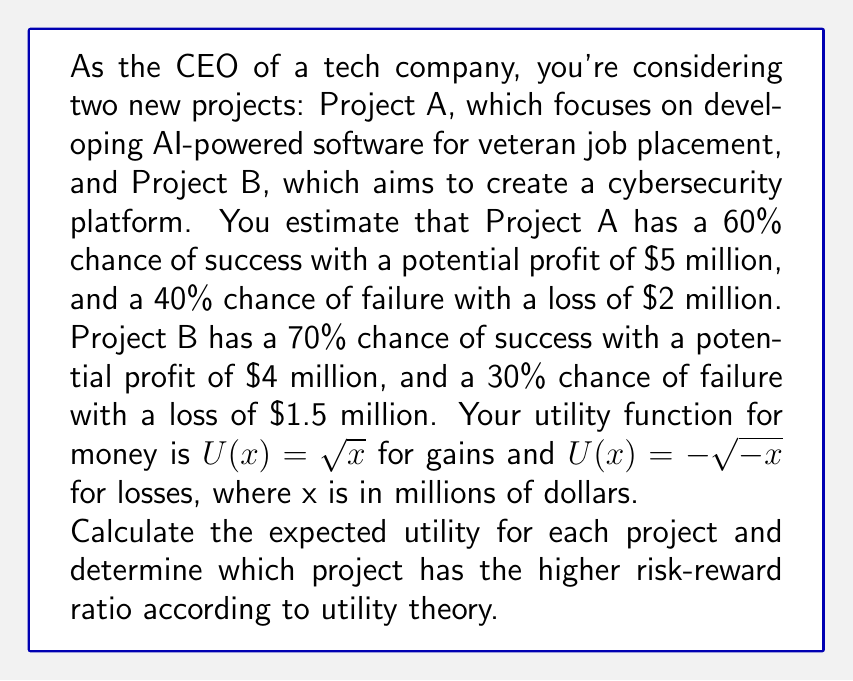Could you help me with this problem? To solve this problem, we need to calculate the expected utility for each project using the given utility function and probability distributions. Then, we'll compare the results to determine which project has the higher risk-reward ratio.

Step 1: Calculate the utility values for each outcome

Project A:
Success: $U(5) = \sqrt{5} \approx 2.236$
Failure: $U(-2) = -\sqrt{2} \approx -1.414$

Project B:
Success: $U(4) = \sqrt{4} = 2$
Failure: $U(-1.5) = -\sqrt{1.5} \approx -1.225$

Step 2: Calculate the expected utility for each project

Expected Utility = (Probability of Success × Utility of Success) + (Probability of Failure × Utility of Failure)

Project A:
$E[U(A)] = 0.60 \times 2.236 + 0.40 \times (-1.414) = 1.3416 - 0.5656 = 0.776$

Project B:
$E[U(B)] = 0.70 \times 2 + 0.30 \times (-1.225) = 1.4 - 0.3675 = 1.0325$

Step 3: Compare the expected utilities

Project B has a higher expected utility (1.0325) compared to Project A (0.776), indicating a better risk-reward ratio according to utility theory.

Step 4: Calculate the risk-reward ratio

To quantify the risk-reward ratio, we can use the coefficient of variation (CV) of the utility values. A lower CV indicates a better risk-reward ratio.

CV = Standard Deviation / Expected Value

For Project A:
$\sigma_A = \sqrt{0.60 \times (2.236 - 0.776)^2 + 0.40 \times (-1.414 - 0.776)^2} \approx 1.6813$
$CV_A = 1.6813 / 0.776 \approx 2.1666$

For Project B:
$\sigma_B = \sqrt{0.70 \times (2 - 1.0325)^2 + 0.30 \times (-1.225 - 1.0325)^2} \approx 1.4175$
$CV_B = 1.4175 / 1.0325 \approx 1.3728$
Answer: Project B has the higher risk-reward ratio according to utility theory, with an expected utility of 1.0325 compared to Project A's 0.776. The coefficient of variation for Project B (1.3728) is lower than Project A (2.1666), further confirming that Project B has a better risk-reward profile. 